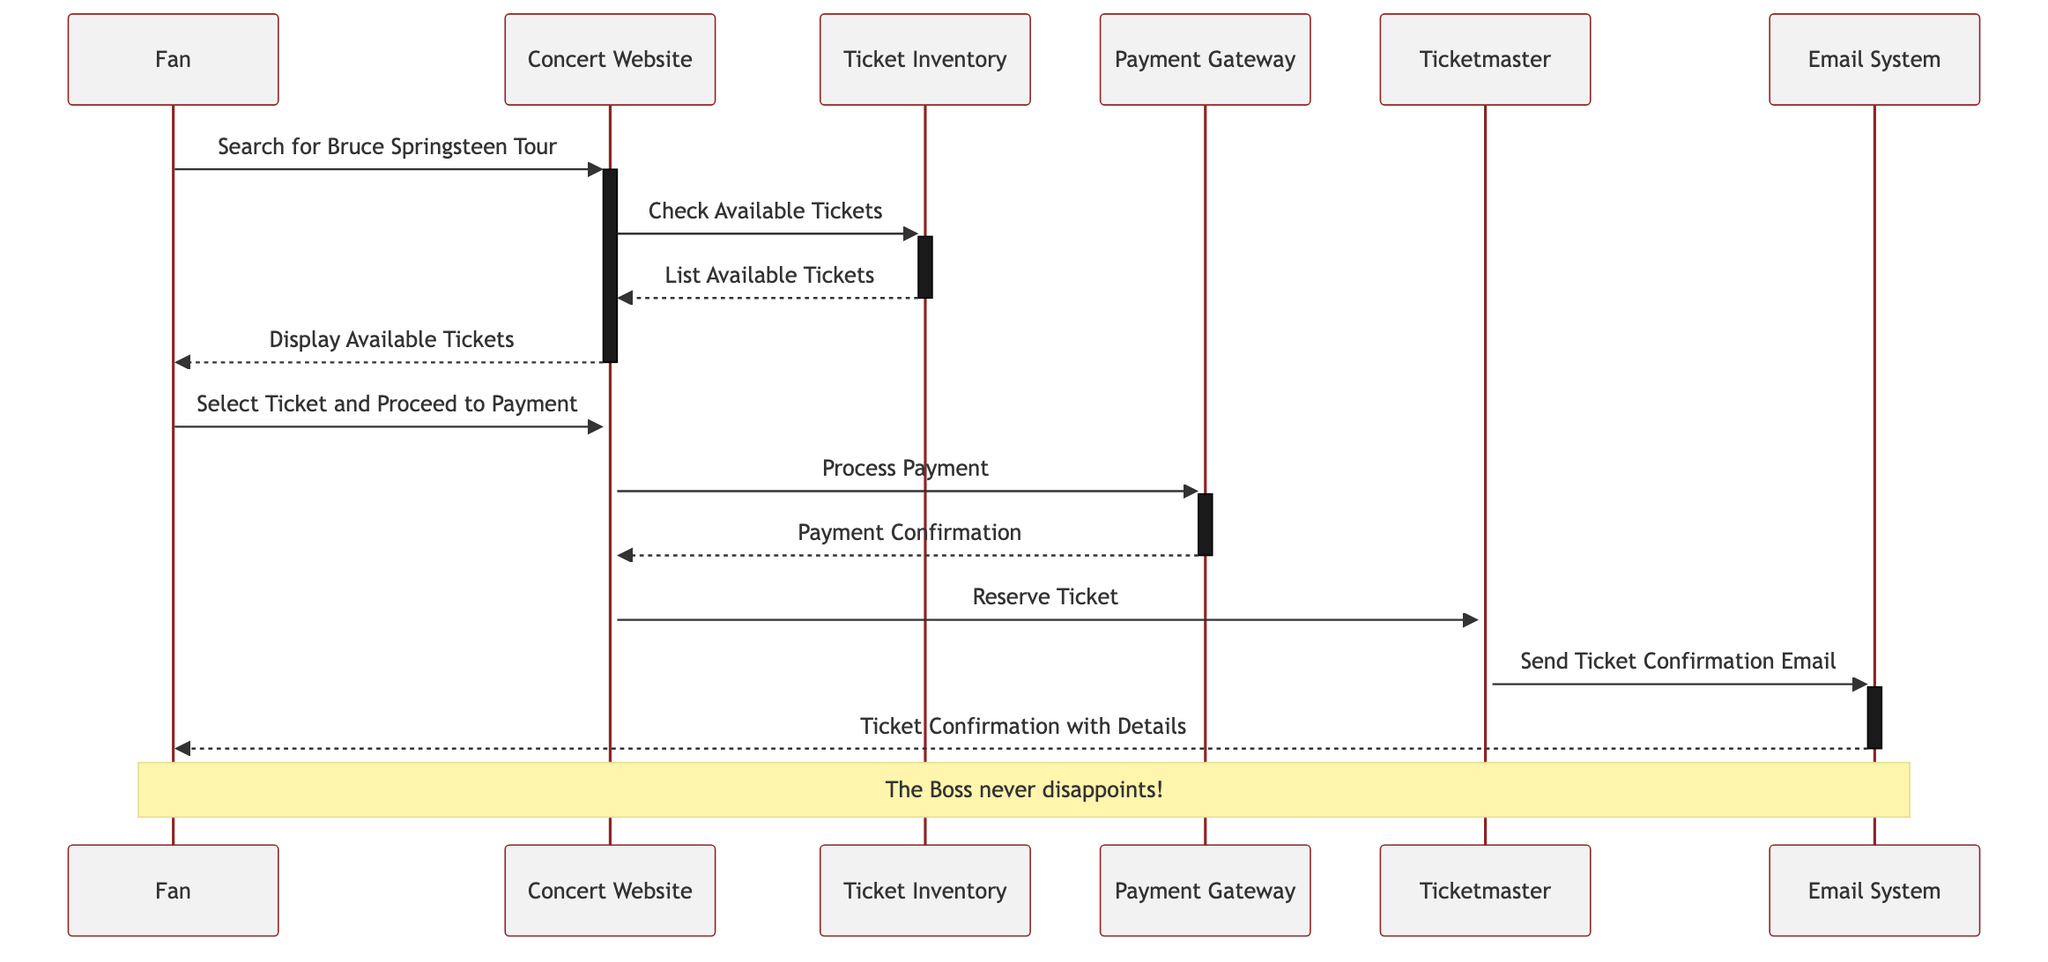What is the first action taken by the Fan? The Fan starts the process by searching for Bruce Springsteen's Tour on the Concert Website, which is the first message in the sequence.
Answer: Search for Bruce Springsteen Tour How many participants are involved in the diagram? There are five distinct participants depicted in the diagram: Fan, Concert Website, Ticket Inventory, Payment Gateway, Ticketmaster, and Email System. Adding them up gives a total of five participants.
Answer: 5 What does the Concert Website do after displaying available tickets? After displaying available tickets to the Fan, the Concert Website processes the payment by sending a request to the Payment Gateway, which is indicated as the next message in the sequence.
Answer: Process Payment Which participant sends the ticket confirmation email? The Ticketmaster is responsible for sending the ticket confirmation email via the Email System, as shown in a message follow-up after reserving the ticket.
Answer: Ticketmaster What is the last confirmation the Fan receives? The last confirmation that the Fan receives is the Ticket Confirmation with Details, sent by the Email System, which concludes the diagram's sequence.
Answer: Ticket Confirmation with Details Why does the Concert Website communicate with the Ticketmaster? The Concert Website communicates with the Ticketmaster to reserve the ticket after confirming the payment with the Payment Gateway and showing the available tickets to the Fan. This step is essential to finalize the ticket purchase.
Answer: Reserve Ticket What message does the Payment Gateway send back to the Concert Website? The Payment Gateway replies with a Payment Confirmation message, indicating that the payment was processed successfully before the reservation step occurs.
Answer: Payment Confirmation What does the Email System do after receiving a request from the Ticketmaster? Upon receiving a request from the Ticketmaster, the Email System sends out the Ticket Confirmation email to the Fan, concluding the ticket purchasing process.
Answer: Send Ticket Confirmation Email How many messages are exchanged in total? Counting all messages exchanged in the sequence, there are ten separate communications in total, each represented as an arrow in the diagram.
Answer: 10 What overall action occurs in the last step of the diagram? The last step of the diagram involves the Email System sending an email to the Fan, providing ticket confirmation details as the final action in the ticket purchasing process.
Answer: Send Ticket Confirmation with Details 